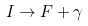Convert formula to latex. <formula><loc_0><loc_0><loc_500><loc_500>I \to F + \gamma</formula> 